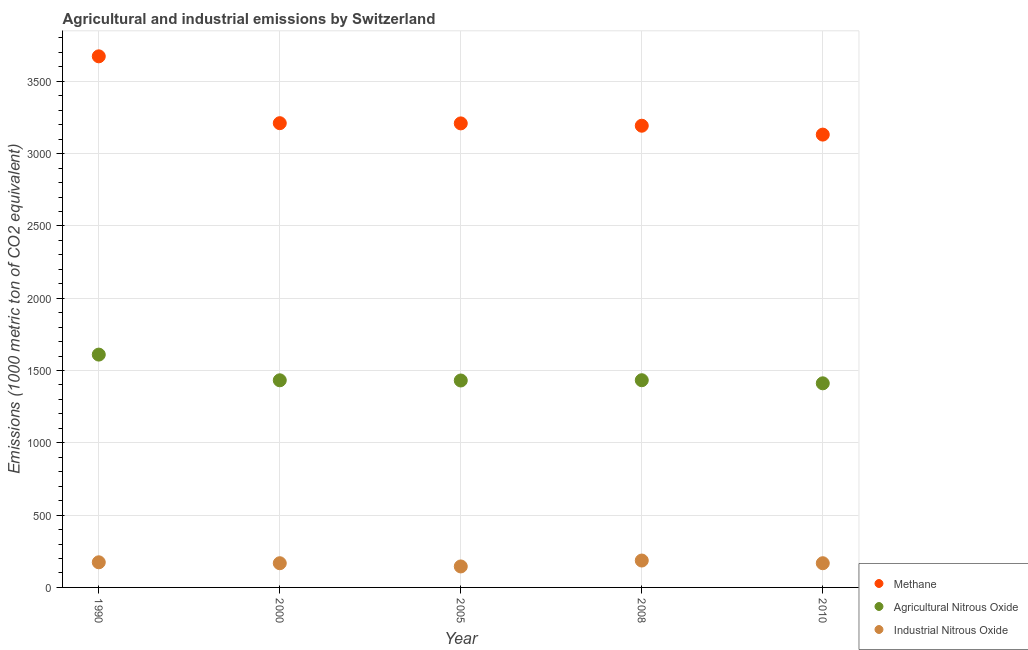How many different coloured dotlines are there?
Your answer should be compact. 3. Is the number of dotlines equal to the number of legend labels?
Provide a short and direct response. Yes. What is the amount of methane emissions in 2010?
Provide a short and direct response. 3131.7. Across all years, what is the maximum amount of methane emissions?
Keep it short and to the point. 3673. Across all years, what is the minimum amount of agricultural nitrous oxide emissions?
Provide a short and direct response. 1411.6. In which year was the amount of methane emissions maximum?
Your answer should be very brief. 1990. In which year was the amount of methane emissions minimum?
Ensure brevity in your answer.  2010. What is the total amount of agricultural nitrous oxide emissions in the graph?
Give a very brief answer. 7318.4. What is the difference between the amount of methane emissions in 1990 and that in 2005?
Offer a terse response. 463.8. What is the difference between the amount of methane emissions in 2010 and the amount of industrial nitrous oxide emissions in 2005?
Provide a short and direct response. 2986.6. What is the average amount of methane emissions per year?
Your response must be concise. 3283.54. In the year 1990, what is the difference between the amount of methane emissions and amount of industrial nitrous oxide emissions?
Ensure brevity in your answer.  3499.2. In how many years, is the amount of methane emissions greater than 2000 metric ton?
Offer a terse response. 5. What is the ratio of the amount of methane emissions in 1990 to that in 2000?
Your answer should be compact. 1.14. Is the amount of methane emissions in 2000 less than that in 2005?
Make the answer very short. No. What is the difference between the highest and the second highest amount of industrial nitrous oxide emissions?
Offer a very short reply. 12.2. What is the difference between the highest and the lowest amount of industrial nitrous oxide emissions?
Your answer should be very brief. 40.9. In how many years, is the amount of methane emissions greater than the average amount of methane emissions taken over all years?
Provide a short and direct response. 1. Is it the case that in every year, the sum of the amount of methane emissions and amount of agricultural nitrous oxide emissions is greater than the amount of industrial nitrous oxide emissions?
Provide a short and direct response. Yes. Does the amount of methane emissions monotonically increase over the years?
Provide a succinct answer. No. Is the amount of industrial nitrous oxide emissions strictly less than the amount of agricultural nitrous oxide emissions over the years?
Provide a succinct answer. Yes. How many dotlines are there?
Provide a short and direct response. 3. What is the difference between two consecutive major ticks on the Y-axis?
Keep it short and to the point. 500. Are the values on the major ticks of Y-axis written in scientific E-notation?
Your response must be concise. No. How many legend labels are there?
Your answer should be very brief. 3. What is the title of the graph?
Your response must be concise. Agricultural and industrial emissions by Switzerland. What is the label or title of the Y-axis?
Make the answer very short. Emissions (1000 metric ton of CO2 equivalent). What is the Emissions (1000 metric ton of CO2 equivalent) in Methane in 1990?
Give a very brief answer. 3673. What is the Emissions (1000 metric ton of CO2 equivalent) in Agricultural Nitrous Oxide in 1990?
Your answer should be compact. 1610.2. What is the Emissions (1000 metric ton of CO2 equivalent) in Industrial Nitrous Oxide in 1990?
Your answer should be very brief. 173.8. What is the Emissions (1000 metric ton of CO2 equivalent) of Methane in 2000?
Provide a succinct answer. 3210.7. What is the Emissions (1000 metric ton of CO2 equivalent) of Agricultural Nitrous Oxide in 2000?
Ensure brevity in your answer.  1432.5. What is the Emissions (1000 metric ton of CO2 equivalent) in Industrial Nitrous Oxide in 2000?
Make the answer very short. 167.4. What is the Emissions (1000 metric ton of CO2 equivalent) in Methane in 2005?
Provide a succinct answer. 3209.2. What is the Emissions (1000 metric ton of CO2 equivalent) of Agricultural Nitrous Oxide in 2005?
Your answer should be compact. 1431.1. What is the Emissions (1000 metric ton of CO2 equivalent) in Industrial Nitrous Oxide in 2005?
Ensure brevity in your answer.  145.1. What is the Emissions (1000 metric ton of CO2 equivalent) in Methane in 2008?
Your answer should be very brief. 3193.1. What is the Emissions (1000 metric ton of CO2 equivalent) of Agricultural Nitrous Oxide in 2008?
Your response must be concise. 1433. What is the Emissions (1000 metric ton of CO2 equivalent) of Industrial Nitrous Oxide in 2008?
Your answer should be compact. 186. What is the Emissions (1000 metric ton of CO2 equivalent) in Methane in 2010?
Your answer should be very brief. 3131.7. What is the Emissions (1000 metric ton of CO2 equivalent) of Agricultural Nitrous Oxide in 2010?
Give a very brief answer. 1411.6. What is the Emissions (1000 metric ton of CO2 equivalent) of Industrial Nitrous Oxide in 2010?
Provide a succinct answer. 167.4. Across all years, what is the maximum Emissions (1000 metric ton of CO2 equivalent) of Methane?
Your answer should be very brief. 3673. Across all years, what is the maximum Emissions (1000 metric ton of CO2 equivalent) of Agricultural Nitrous Oxide?
Keep it short and to the point. 1610.2. Across all years, what is the maximum Emissions (1000 metric ton of CO2 equivalent) of Industrial Nitrous Oxide?
Your answer should be very brief. 186. Across all years, what is the minimum Emissions (1000 metric ton of CO2 equivalent) of Methane?
Make the answer very short. 3131.7. Across all years, what is the minimum Emissions (1000 metric ton of CO2 equivalent) in Agricultural Nitrous Oxide?
Provide a short and direct response. 1411.6. Across all years, what is the minimum Emissions (1000 metric ton of CO2 equivalent) of Industrial Nitrous Oxide?
Provide a short and direct response. 145.1. What is the total Emissions (1000 metric ton of CO2 equivalent) in Methane in the graph?
Give a very brief answer. 1.64e+04. What is the total Emissions (1000 metric ton of CO2 equivalent) of Agricultural Nitrous Oxide in the graph?
Your answer should be very brief. 7318.4. What is the total Emissions (1000 metric ton of CO2 equivalent) in Industrial Nitrous Oxide in the graph?
Your answer should be very brief. 839.7. What is the difference between the Emissions (1000 metric ton of CO2 equivalent) in Methane in 1990 and that in 2000?
Keep it short and to the point. 462.3. What is the difference between the Emissions (1000 metric ton of CO2 equivalent) in Agricultural Nitrous Oxide in 1990 and that in 2000?
Ensure brevity in your answer.  177.7. What is the difference between the Emissions (1000 metric ton of CO2 equivalent) of Methane in 1990 and that in 2005?
Your answer should be very brief. 463.8. What is the difference between the Emissions (1000 metric ton of CO2 equivalent) in Agricultural Nitrous Oxide in 1990 and that in 2005?
Keep it short and to the point. 179.1. What is the difference between the Emissions (1000 metric ton of CO2 equivalent) of Industrial Nitrous Oxide in 1990 and that in 2005?
Your answer should be compact. 28.7. What is the difference between the Emissions (1000 metric ton of CO2 equivalent) in Methane in 1990 and that in 2008?
Offer a terse response. 479.9. What is the difference between the Emissions (1000 metric ton of CO2 equivalent) of Agricultural Nitrous Oxide in 1990 and that in 2008?
Keep it short and to the point. 177.2. What is the difference between the Emissions (1000 metric ton of CO2 equivalent) of Industrial Nitrous Oxide in 1990 and that in 2008?
Provide a succinct answer. -12.2. What is the difference between the Emissions (1000 metric ton of CO2 equivalent) of Methane in 1990 and that in 2010?
Provide a succinct answer. 541.3. What is the difference between the Emissions (1000 metric ton of CO2 equivalent) of Agricultural Nitrous Oxide in 1990 and that in 2010?
Provide a short and direct response. 198.6. What is the difference between the Emissions (1000 metric ton of CO2 equivalent) in Industrial Nitrous Oxide in 2000 and that in 2005?
Your answer should be compact. 22.3. What is the difference between the Emissions (1000 metric ton of CO2 equivalent) in Methane in 2000 and that in 2008?
Your response must be concise. 17.6. What is the difference between the Emissions (1000 metric ton of CO2 equivalent) in Agricultural Nitrous Oxide in 2000 and that in 2008?
Keep it short and to the point. -0.5. What is the difference between the Emissions (1000 metric ton of CO2 equivalent) in Industrial Nitrous Oxide in 2000 and that in 2008?
Your response must be concise. -18.6. What is the difference between the Emissions (1000 metric ton of CO2 equivalent) in Methane in 2000 and that in 2010?
Provide a short and direct response. 79. What is the difference between the Emissions (1000 metric ton of CO2 equivalent) in Agricultural Nitrous Oxide in 2000 and that in 2010?
Make the answer very short. 20.9. What is the difference between the Emissions (1000 metric ton of CO2 equivalent) in Industrial Nitrous Oxide in 2000 and that in 2010?
Your response must be concise. 0. What is the difference between the Emissions (1000 metric ton of CO2 equivalent) in Industrial Nitrous Oxide in 2005 and that in 2008?
Your answer should be compact. -40.9. What is the difference between the Emissions (1000 metric ton of CO2 equivalent) in Methane in 2005 and that in 2010?
Your answer should be very brief. 77.5. What is the difference between the Emissions (1000 metric ton of CO2 equivalent) of Industrial Nitrous Oxide in 2005 and that in 2010?
Make the answer very short. -22.3. What is the difference between the Emissions (1000 metric ton of CO2 equivalent) of Methane in 2008 and that in 2010?
Your response must be concise. 61.4. What is the difference between the Emissions (1000 metric ton of CO2 equivalent) of Agricultural Nitrous Oxide in 2008 and that in 2010?
Provide a succinct answer. 21.4. What is the difference between the Emissions (1000 metric ton of CO2 equivalent) of Methane in 1990 and the Emissions (1000 metric ton of CO2 equivalent) of Agricultural Nitrous Oxide in 2000?
Provide a succinct answer. 2240.5. What is the difference between the Emissions (1000 metric ton of CO2 equivalent) in Methane in 1990 and the Emissions (1000 metric ton of CO2 equivalent) in Industrial Nitrous Oxide in 2000?
Make the answer very short. 3505.6. What is the difference between the Emissions (1000 metric ton of CO2 equivalent) in Agricultural Nitrous Oxide in 1990 and the Emissions (1000 metric ton of CO2 equivalent) in Industrial Nitrous Oxide in 2000?
Your answer should be very brief. 1442.8. What is the difference between the Emissions (1000 metric ton of CO2 equivalent) of Methane in 1990 and the Emissions (1000 metric ton of CO2 equivalent) of Agricultural Nitrous Oxide in 2005?
Ensure brevity in your answer.  2241.9. What is the difference between the Emissions (1000 metric ton of CO2 equivalent) of Methane in 1990 and the Emissions (1000 metric ton of CO2 equivalent) of Industrial Nitrous Oxide in 2005?
Offer a terse response. 3527.9. What is the difference between the Emissions (1000 metric ton of CO2 equivalent) in Agricultural Nitrous Oxide in 1990 and the Emissions (1000 metric ton of CO2 equivalent) in Industrial Nitrous Oxide in 2005?
Your answer should be compact. 1465.1. What is the difference between the Emissions (1000 metric ton of CO2 equivalent) in Methane in 1990 and the Emissions (1000 metric ton of CO2 equivalent) in Agricultural Nitrous Oxide in 2008?
Offer a very short reply. 2240. What is the difference between the Emissions (1000 metric ton of CO2 equivalent) in Methane in 1990 and the Emissions (1000 metric ton of CO2 equivalent) in Industrial Nitrous Oxide in 2008?
Give a very brief answer. 3487. What is the difference between the Emissions (1000 metric ton of CO2 equivalent) in Agricultural Nitrous Oxide in 1990 and the Emissions (1000 metric ton of CO2 equivalent) in Industrial Nitrous Oxide in 2008?
Make the answer very short. 1424.2. What is the difference between the Emissions (1000 metric ton of CO2 equivalent) in Methane in 1990 and the Emissions (1000 metric ton of CO2 equivalent) in Agricultural Nitrous Oxide in 2010?
Provide a short and direct response. 2261.4. What is the difference between the Emissions (1000 metric ton of CO2 equivalent) of Methane in 1990 and the Emissions (1000 metric ton of CO2 equivalent) of Industrial Nitrous Oxide in 2010?
Give a very brief answer. 3505.6. What is the difference between the Emissions (1000 metric ton of CO2 equivalent) of Agricultural Nitrous Oxide in 1990 and the Emissions (1000 metric ton of CO2 equivalent) of Industrial Nitrous Oxide in 2010?
Your response must be concise. 1442.8. What is the difference between the Emissions (1000 metric ton of CO2 equivalent) of Methane in 2000 and the Emissions (1000 metric ton of CO2 equivalent) of Agricultural Nitrous Oxide in 2005?
Offer a very short reply. 1779.6. What is the difference between the Emissions (1000 metric ton of CO2 equivalent) in Methane in 2000 and the Emissions (1000 metric ton of CO2 equivalent) in Industrial Nitrous Oxide in 2005?
Provide a short and direct response. 3065.6. What is the difference between the Emissions (1000 metric ton of CO2 equivalent) of Agricultural Nitrous Oxide in 2000 and the Emissions (1000 metric ton of CO2 equivalent) of Industrial Nitrous Oxide in 2005?
Your answer should be very brief. 1287.4. What is the difference between the Emissions (1000 metric ton of CO2 equivalent) in Methane in 2000 and the Emissions (1000 metric ton of CO2 equivalent) in Agricultural Nitrous Oxide in 2008?
Give a very brief answer. 1777.7. What is the difference between the Emissions (1000 metric ton of CO2 equivalent) in Methane in 2000 and the Emissions (1000 metric ton of CO2 equivalent) in Industrial Nitrous Oxide in 2008?
Provide a succinct answer. 3024.7. What is the difference between the Emissions (1000 metric ton of CO2 equivalent) of Agricultural Nitrous Oxide in 2000 and the Emissions (1000 metric ton of CO2 equivalent) of Industrial Nitrous Oxide in 2008?
Provide a short and direct response. 1246.5. What is the difference between the Emissions (1000 metric ton of CO2 equivalent) in Methane in 2000 and the Emissions (1000 metric ton of CO2 equivalent) in Agricultural Nitrous Oxide in 2010?
Ensure brevity in your answer.  1799.1. What is the difference between the Emissions (1000 metric ton of CO2 equivalent) of Methane in 2000 and the Emissions (1000 metric ton of CO2 equivalent) of Industrial Nitrous Oxide in 2010?
Give a very brief answer. 3043.3. What is the difference between the Emissions (1000 metric ton of CO2 equivalent) in Agricultural Nitrous Oxide in 2000 and the Emissions (1000 metric ton of CO2 equivalent) in Industrial Nitrous Oxide in 2010?
Your response must be concise. 1265.1. What is the difference between the Emissions (1000 metric ton of CO2 equivalent) in Methane in 2005 and the Emissions (1000 metric ton of CO2 equivalent) in Agricultural Nitrous Oxide in 2008?
Your answer should be compact. 1776.2. What is the difference between the Emissions (1000 metric ton of CO2 equivalent) in Methane in 2005 and the Emissions (1000 metric ton of CO2 equivalent) in Industrial Nitrous Oxide in 2008?
Ensure brevity in your answer.  3023.2. What is the difference between the Emissions (1000 metric ton of CO2 equivalent) of Agricultural Nitrous Oxide in 2005 and the Emissions (1000 metric ton of CO2 equivalent) of Industrial Nitrous Oxide in 2008?
Keep it short and to the point. 1245.1. What is the difference between the Emissions (1000 metric ton of CO2 equivalent) of Methane in 2005 and the Emissions (1000 metric ton of CO2 equivalent) of Agricultural Nitrous Oxide in 2010?
Ensure brevity in your answer.  1797.6. What is the difference between the Emissions (1000 metric ton of CO2 equivalent) in Methane in 2005 and the Emissions (1000 metric ton of CO2 equivalent) in Industrial Nitrous Oxide in 2010?
Ensure brevity in your answer.  3041.8. What is the difference between the Emissions (1000 metric ton of CO2 equivalent) in Agricultural Nitrous Oxide in 2005 and the Emissions (1000 metric ton of CO2 equivalent) in Industrial Nitrous Oxide in 2010?
Your answer should be compact. 1263.7. What is the difference between the Emissions (1000 metric ton of CO2 equivalent) of Methane in 2008 and the Emissions (1000 metric ton of CO2 equivalent) of Agricultural Nitrous Oxide in 2010?
Make the answer very short. 1781.5. What is the difference between the Emissions (1000 metric ton of CO2 equivalent) in Methane in 2008 and the Emissions (1000 metric ton of CO2 equivalent) in Industrial Nitrous Oxide in 2010?
Provide a succinct answer. 3025.7. What is the difference between the Emissions (1000 metric ton of CO2 equivalent) in Agricultural Nitrous Oxide in 2008 and the Emissions (1000 metric ton of CO2 equivalent) in Industrial Nitrous Oxide in 2010?
Your answer should be compact. 1265.6. What is the average Emissions (1000 metric ton of CO2 equivalent) in Methane per year?
Your answer should be very brief. 3283.54. What is the average Emissions (1000 metric ton of CO2 equivalent) of Agricultural Nitrous Oxide per year?
Offer a very short reply. 1463.68. What is the average Emissions (1000 metric ton of CO2 equivalent) of Industrial Nitrous Oxide per year?
Your response must be concise. 167.94. In the year 1990, what is the difference between the Emissions (1000 metric ton of CO2 equivalent) of Methane and Emissions (1000 metric ton of CO2 equivalent) of Agricultural Nitrous Oxide?
Your response must be concise. 2062.8. In the year 1990, what is the difference between the Emissions (1000 metric ton of CO2 equivalent) of Methane and Emissions (1000 metric ton of CO2 equivalent) of Industrial Nitrous Oxide?
Your answer should be very brief. 3499.2. In the year 1990, what is the difference between the Emissions (1000 metric ton of CO2 equivalent) in Agricultural Nitrous Oxide and Emissions (1000 metric ton of CO2 equivalent) in Industrial Nitrous Oxide?
Offer a very short reply. 1436.4. In the year 2000, what is the difference between the Emissions (1000 metric ton of CO2 equivalent) of Methane and Emissions (1000 metric ton of CO2 equivalent) of Agricultural Nitrous Oxide?
Keep it short and to the point. 1778.2. In the year 2000, what is the difference between the Emissions (1000 metric ton of CO2 equivalent) of Methane and Emissions (1000 metric ton of CO2 equivalent) of Industrial Nitrous Oxide?
Your answer should be very brief. 3043.3. In the year 2000, what is the difference between the Emissions (1000 metric ton of CO2 equivalent) of Agricultural Nitrous Oxide and Emissions (1000 metric ton of CO2 equivalent) of Industrial Nitrous Oxide?
Provide a succinct answer. 1265.1. In the year 2005, what is the difference between the Emissions (1000 metric ton of CO2 equivalent) of Methane and Emissions (1000 metric ton of CO2 equivalent) of Agricultural Nitrous Oxide?
Keep it short and to the point. 1778.1. In the year 2005, what is the difference between the Emissions (1000 metric ton of CO2 equivalent) of Methane and Emissions (1000 metric ton of CO2 equivalent) of Industrial Nitrous Oxide?
Offer a very short reply. 3064.1. In the year 2005, what is the difference between the Emissions (1000 metric ton of CO2 equivalent) in Agricultural Nitrous Oxide and Emissions (1000 metric ton of CO2 equivalent) in Industrial Nitrous Oxide?
Give a very brief answer. 1286. In the year 2008, what is the difference between the Emissions (1000 metric ton of CO2 equivalent) of Methane and Emissions (1000 metric ton of CO2 equivalent) of Agricultural Nitrous Oxide?
Provide a succinct answer. 1760.1. In the year 2008, what is the difference between the Emissions (1000 metric ton of CO2 equivalent) of Methane and Emissions (1000 metric ton of CO2 equivalent) of Industrial Nitrous Oxide?
Your response must be concise. 3007.1. In the year 2008, what is the difference between the Emissions (1000 metric ton of CO2 equivalent) of Agricultural Nitrous Oxide and Emissions (1000 metric ton of CO2 equivalent) of Industrial Nitrous Oxide?
Your answer should be compact. 1247. In the year 2010, what is the difference between the Emissions (1000 metric ton of CO2 equivalent) of Methane and Emissions (1000 metric ton of CO2 equivalent) of Agricultural Nitrous Oxide?
Offer a very short reply. 1720.1. In the year 2010, what is the difference between the Emissions (1000 metric ton of CO2 equivalent) in Methane and Emissions (1000 metric ton of CO2 equivalent) in Industrial Nitrous Oxide?
Provide a short and direct response. 2964.3. In the year 2010, what is the difference between the Emissions (1000 metric ton of CO2 equivalent) of Agricultural Nitrous Oxide and Emissions (1000 metric ton of CO2 equivalent) of Industrial Nitrous Oxide?
Offer a terse response. 1244.2. What is the ratio of the Emissions (1000 metric ton of CO2 equivalent) in Methane in 1990 to that in 2000?
Ensure brevity in your answer.  1.14. What is the ratio of the Emissions (1000 metric ton of CO2 equivalent) of Agricultural Nitrous Oxide in 1990 to that in 2000?
Make the answer very short. 1.12. What is the ratio of the Emissions (1000 metric ton of CO2 equivalent) of Industrial Nitrous Oxide in 1990 to that in 2000?
Provide a succinct answer. 1.04. What is the ratio of the Emissions (1000 metric ton of CO2 equivalent) in Methane in 1990 to that in 2005?
Your response must be concise. 1.14. What is the ratio of the Emissions (1000 metric ton of CO2 equivalent) in Agricultural Nitrous Oxide in 1990 to that in 2005?
Provide a short and direct response. 1.13. What is the ratio of the Emissions (1000 metric ton of CO2 equivalent) of Industrial Nitrous Oxide in 1990 to that in 2005?
Ensure brevity in your answer.  1.2. What is the ratio of the Emissions (1000 metric ton of CO2 equivalent) in Methane in 1990 to that in 2008?
Provide a short and direct response. 1.15. What is the ratio of the Emissions (1000 metric ton of CO2 equivalent) of Agricultural Nitrous Oxide in 1990 to that in 2008?
Your answer should be very brief. 1.12. What is the ratio of the Emissions (1000 metric ton of CO2 equivalent) of Industrial Nitrous Oxide in 1990 to that in 2008?
Offer a terse response. 0.93. What is the ratio of the Emissions (1000 metric ton of CO2 equivalent) in Methane in 1990 to that in 2010?
Offer a very short reply. 1.17. What is the ratio of the Emissions (1000 metric ton of CO2 equivalent) of Agricultural Nitrous Oxide in 1990 to that in 2010?
Ensure brevity in your answer.  1.14. What is the ratio of the Emissions (1000 metric ton of CO2 equivalent) of Industrial Nitrous Oxide in 1990 to that in 2010?
Ensure brevity in your answer.  1.04. What is the ratio of the Emissions (1000 metric ton of CO2 equivalent) of Industrial Nitrous Oxide in 2000 to that in 2005?
Make the answer very short. 1.15. What is the ratio of the Emissions (1000 metric ton of CO2 equivalent) in Methane in 2000 to that in 2008?
Provide a succinct answer. 1.01. What is the ratio of the Emissions (1000 metric ton of CO2 equivalent) of Agricultural Nitrous Oxide in 2000 to that in 2008?
Give a very brief answer. 1. What is the ratio of the Emissions (1000 metric ton of CO2 equivalent) of Methane in 2000 to that in 2010?
Keep it short and to the point. 1.03. What is the ratio of the Emissions (1000 metric ton of CO2 equivalent) of Agricultural Nitrous Oxide in 2000 to that in 2010?
Make the answer very short. 1.01. What is the ratio of the Emissions (1000 metric ton of CO2 equivalent) in Industrial Nitrous Oxide in 2000 to that in 2010?
Your response must be concise. 1. What is the ratio of the Emissions (1000 metric ton of CO2 equivalent) of Agricultural Nitrous Oxide in 2005 to that in 2008?
Make the answer very short. 1. What is the ratio of the Emissions (1000 metric ton of CO2 equivalent) in Industrial Nitrous Oxide in 2005 to that in 2008?
Offer a very short reply. 0.78. What is the ratio of the Emissions (1000 metric ton of CO2 equivalent) in Methane in 2005 to that in 2010?
Your answer should be very brief. 1.02. What is the ratio of the Emissions (1000 metric ton of CO2 equivalent) of Agricultural Nitrous Oxide in 2005 to that in 2010?
Make the answer very short. 1.01. What is the ratio of the Emissions (1000 metric ton of CO2 equivalent) in Industrial Nitrous Oxide in 2005 to that in 2010?
Give a very brief answer. 0.87. What is the ratio of the Emissions (1000 metric ton of CO2 equivalent) of Methane in 2008 to that in 2010?
Offer a very short reply. 1.02. What is the ratio of the Emissions (1000 metric ton of CO2 equivalent) of Agricultural Nitrous Oxide in 2008 to that in 2010?
Keep it short and to the point. 1.02. What is the ratio of the Emissions (1000 metric ton of CO2 equivalent) of Industrial Nitrous Oxide in 2008 to that in 2010?
Keep it short and to the point. 1.11. What is the difference between the highest and the second highest Emissions (1000 metric ton of CO2 equivalent) of Methane?
Your response must be concise. 462.3. What is the difference between the highest and the second highest Emissions (1000 metric ton of CO2 equivalent) of Agricultural Nitrous Oxide?
Give a very brief answer. 177.2. What is the difference between the highest and the lowest Emissions (1000 metric ton of CO2 equivalent) in Methane?
Provide a succinct answer. 541.3. What is the difference between the highest and the lowest Emissions (1000 metric ton of CO2 equivalent) of Agricultural Nitrous Oxide?
Keep it short and to the point. 198.6. What is the difference between the highest and the lowest Emissions (1000 metric ton of CO2 equivalent) in Industrial Nitrous Oxide?
Your answer should be very brief. 40.9. 